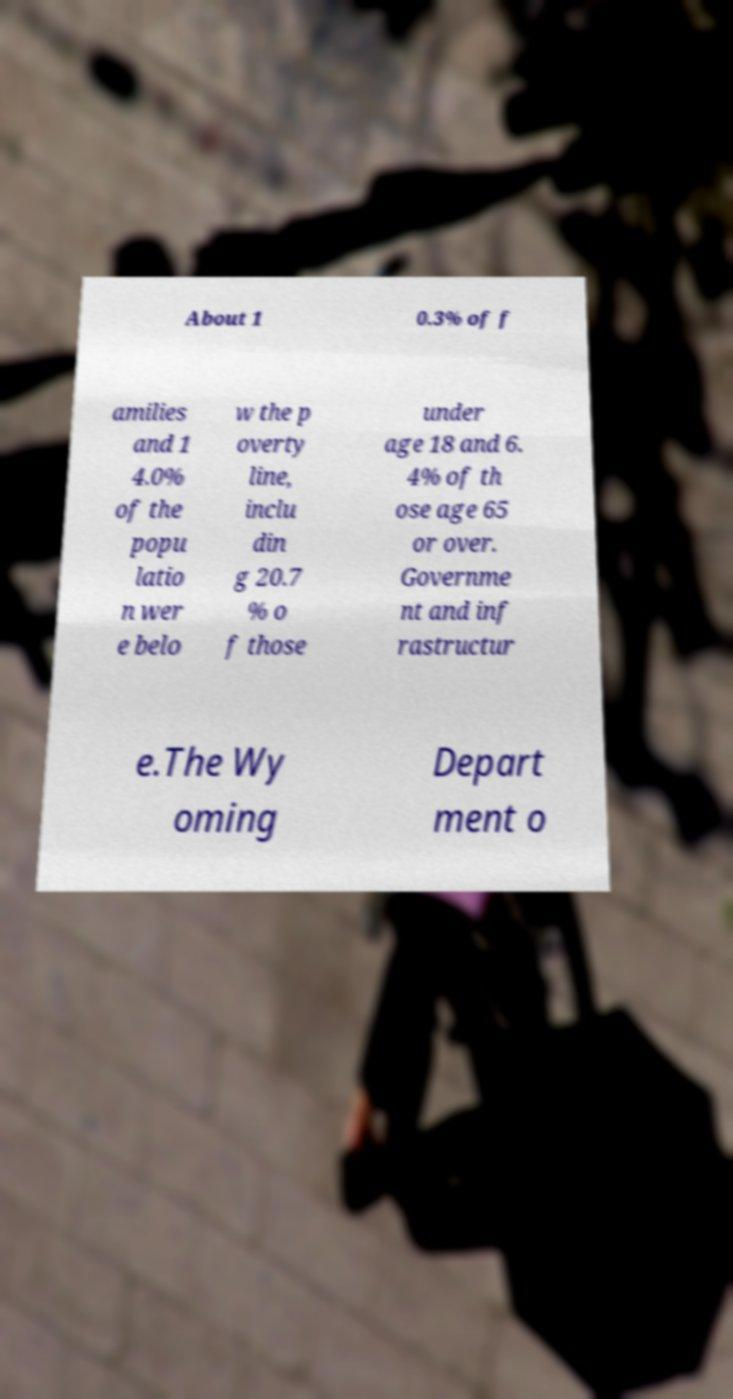What messages or text are displayed in this image? I need them in a readable, typed format. About 1 0.3% of f amilies and 1 4.0% of the popu latio n wer e belo w the p overty line, inclu din g 20.7 % o f those under age 18 and 6. 4% of th ose age 65 or over. Governme nt and inf rastructur e.The Wy oming Depart ment o 